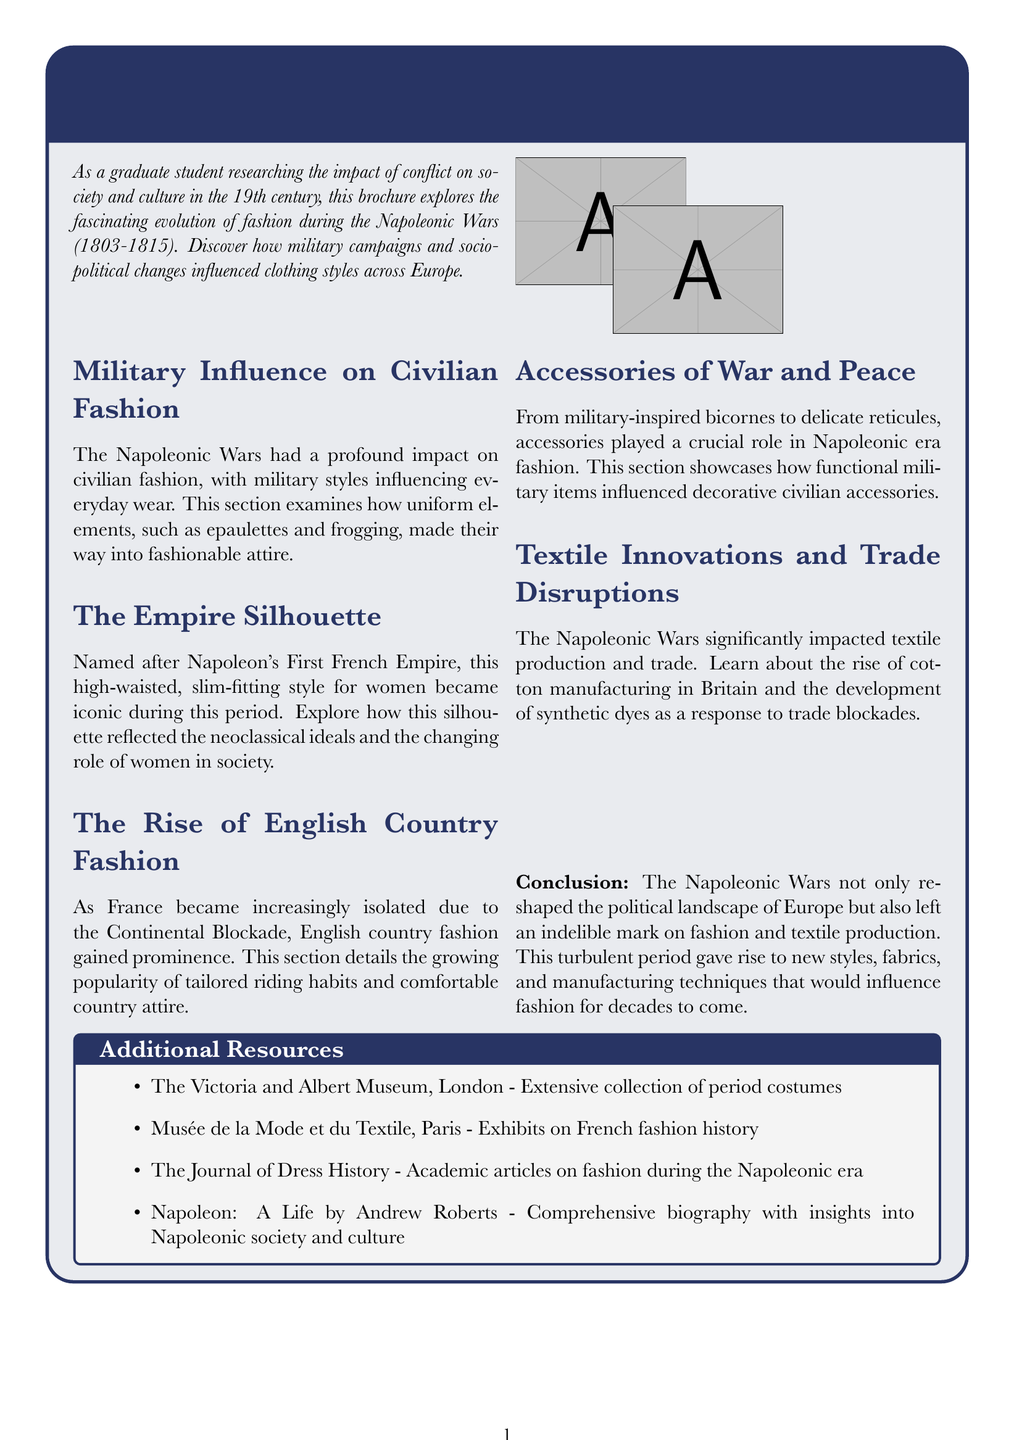What is the title of the brochure? The title of the brochure is provided at the beginning of the document and is "Fashion in the Napoleonic Era: A Sartorial Revolution."
Answer: Fashion in the Napoleonic Era: A Sartorial Revolution What years do the Napoleonic Wars span? The introductory section notes the timeframe of the Napoleonic Wars as 1803-1815.
Answer: 1803-1815 Which style became iconic for women during the Napoleonic era? The section on “The Empire Silhouette” describes the high-waisted, slim-fitting style for women that became iconic.
Answer: Empire Silhouette What type of fabric is commonly used for military uniforms? In the section titled "Military Influence on Civilian Fashion," it is mentioned that wool broadcloth was commonly used for military uniforms.
Answer: Wool broadcloth What significant impact did the Napoleonic Wars have on textile production? The section on "Textile Innovations and Trade Disruptions" highlights the rise of cotton manufacturing in Britain as a significant impact of the Napoleonic Wars.
Answer: Rise of cotton manufacturing Which accessory is influenced by military items? The section "Accessories of War and Peace" indicates that accessories like bicorne hats were influenced by military items.
Answer: Bicornes How did the Continental Blockade affect fashion? The rise of English country fashion became prominent as France became isolated due to the Continental Blockade, as discussed in its respective section.
Answer: English country fashion What type of museum is mentioned as an additional resource? The brochure mentions "The Victoria and Albert Museum" as an extensive collection of period costumes.
Answer: Museum What does the brochure suggest about the relationship between conflict and fashion? The conclusion discusses how the Napoleonic Wars influenced fashion and textile production, establishing a connection between conflict and fashion changes.
Answer: Influence on fashion and textile production 